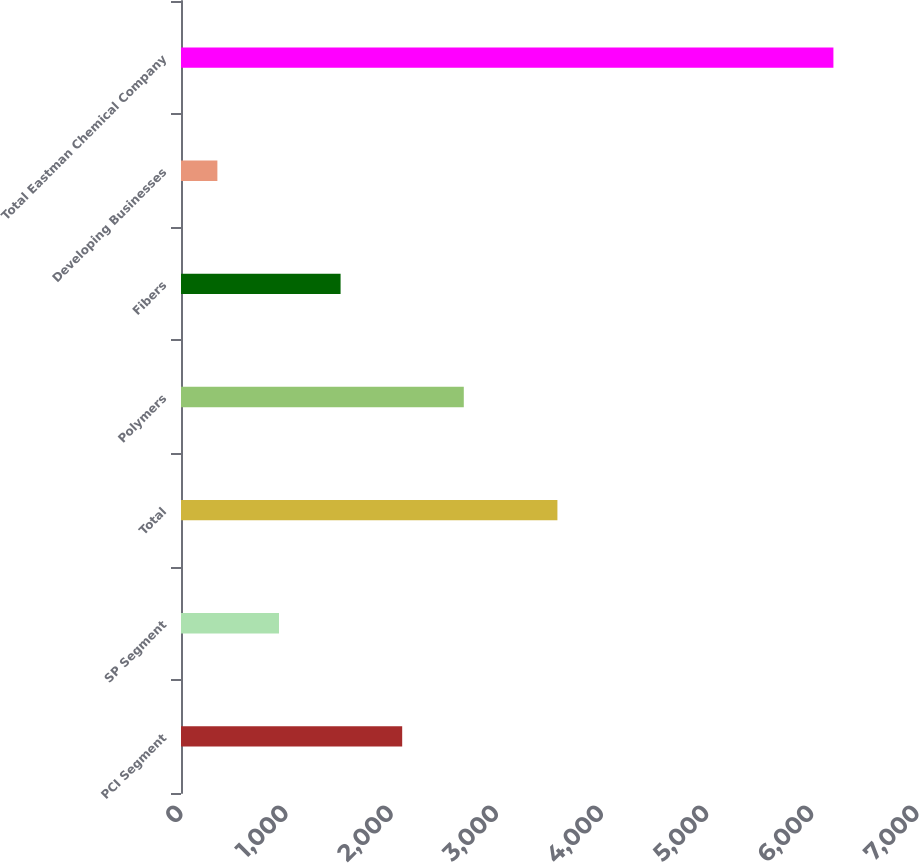Convert chart to OTSL. <chart><loc_0><loc_0><loc_500><loc_500><bar_chart><fcel>PCI Segment<fcel>SP Segment<fcel>Total<fcel>Polymers<fcel>Fibers<fcel>Developing Businesses<fcel>Total Eastman Chemical Company<nl><fcel>2103.7<fcel>931.9<fcel>3580<fcel>2689.6<fcel>1517.8<fcel>346<fcel>6205<nl></chart> 